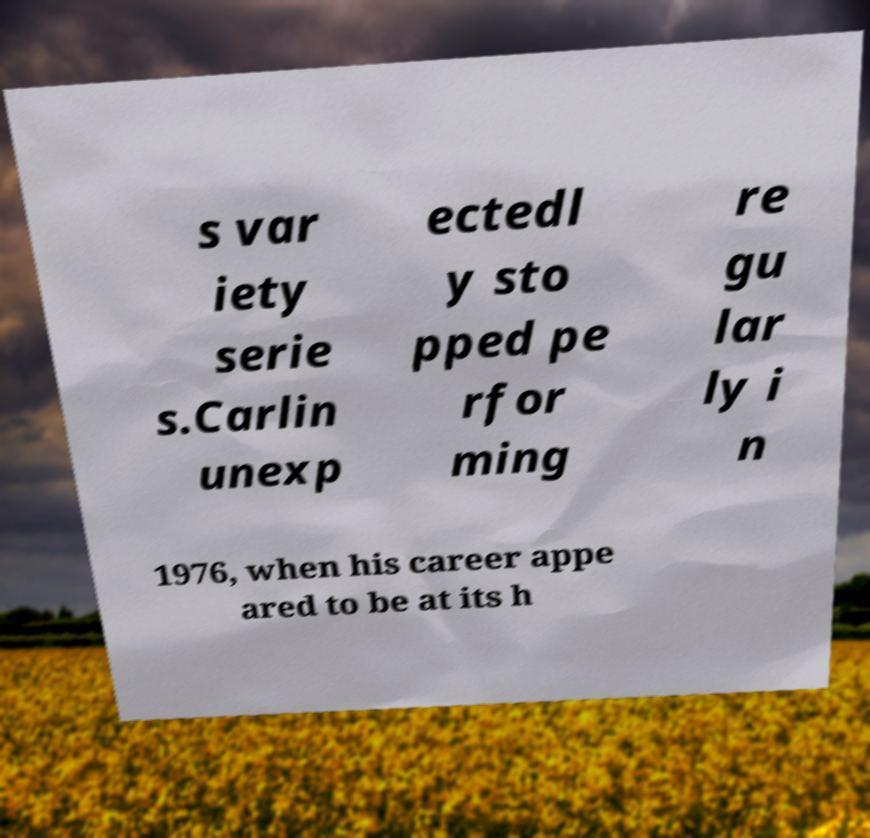Can you read and provide the text displayed in the image?This photo seems to have some interesting text. Can you extract and type it out for me? s var iety serie s.Carlin unexp ectedl y sto pped pe rfor ming re gu lar ly i n 1976, when his career appe ared to be at its h 